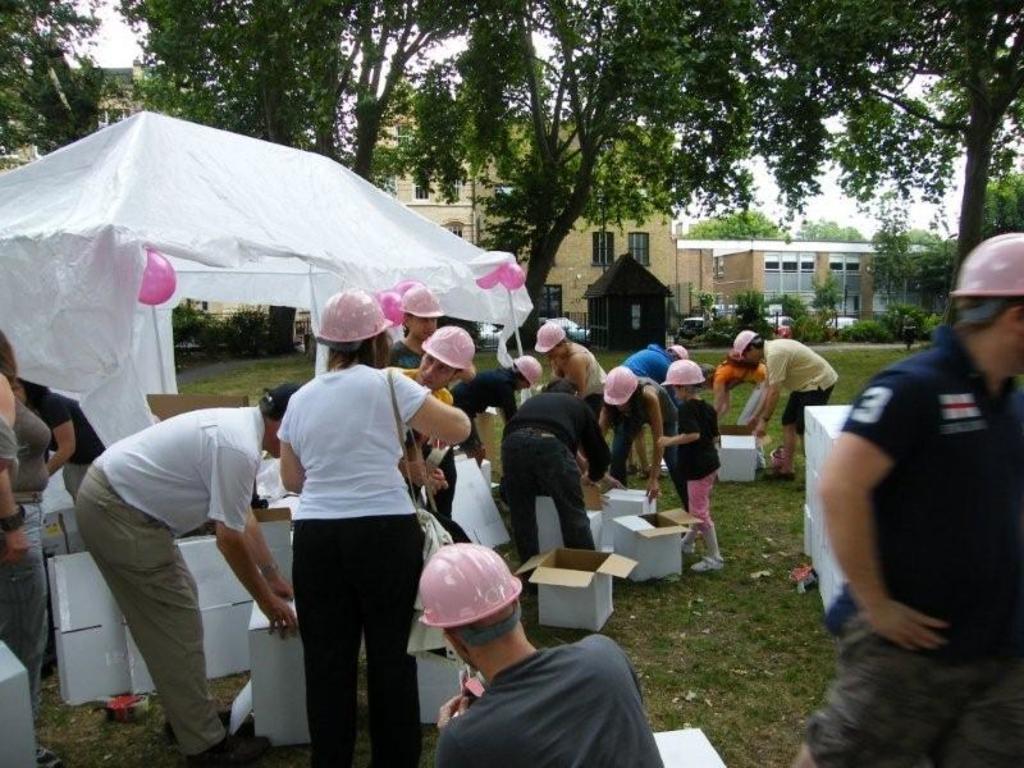Please provide a concise description of this image. In this image we can see many persons standing on the grass and wearing caps. at the bottom there are boxes. On the left side of the image we can see balloons and tent. In the background we can see trees, grass, plants, cars, buildings and sky. 